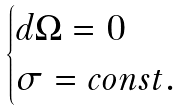Convert formula to latex. <formula><loc_0><loc_0><loc_500><loc_500>\begin{cases} d \Omega = 0 \\ \sigma = c o n s t . \end{cases}</formula> 